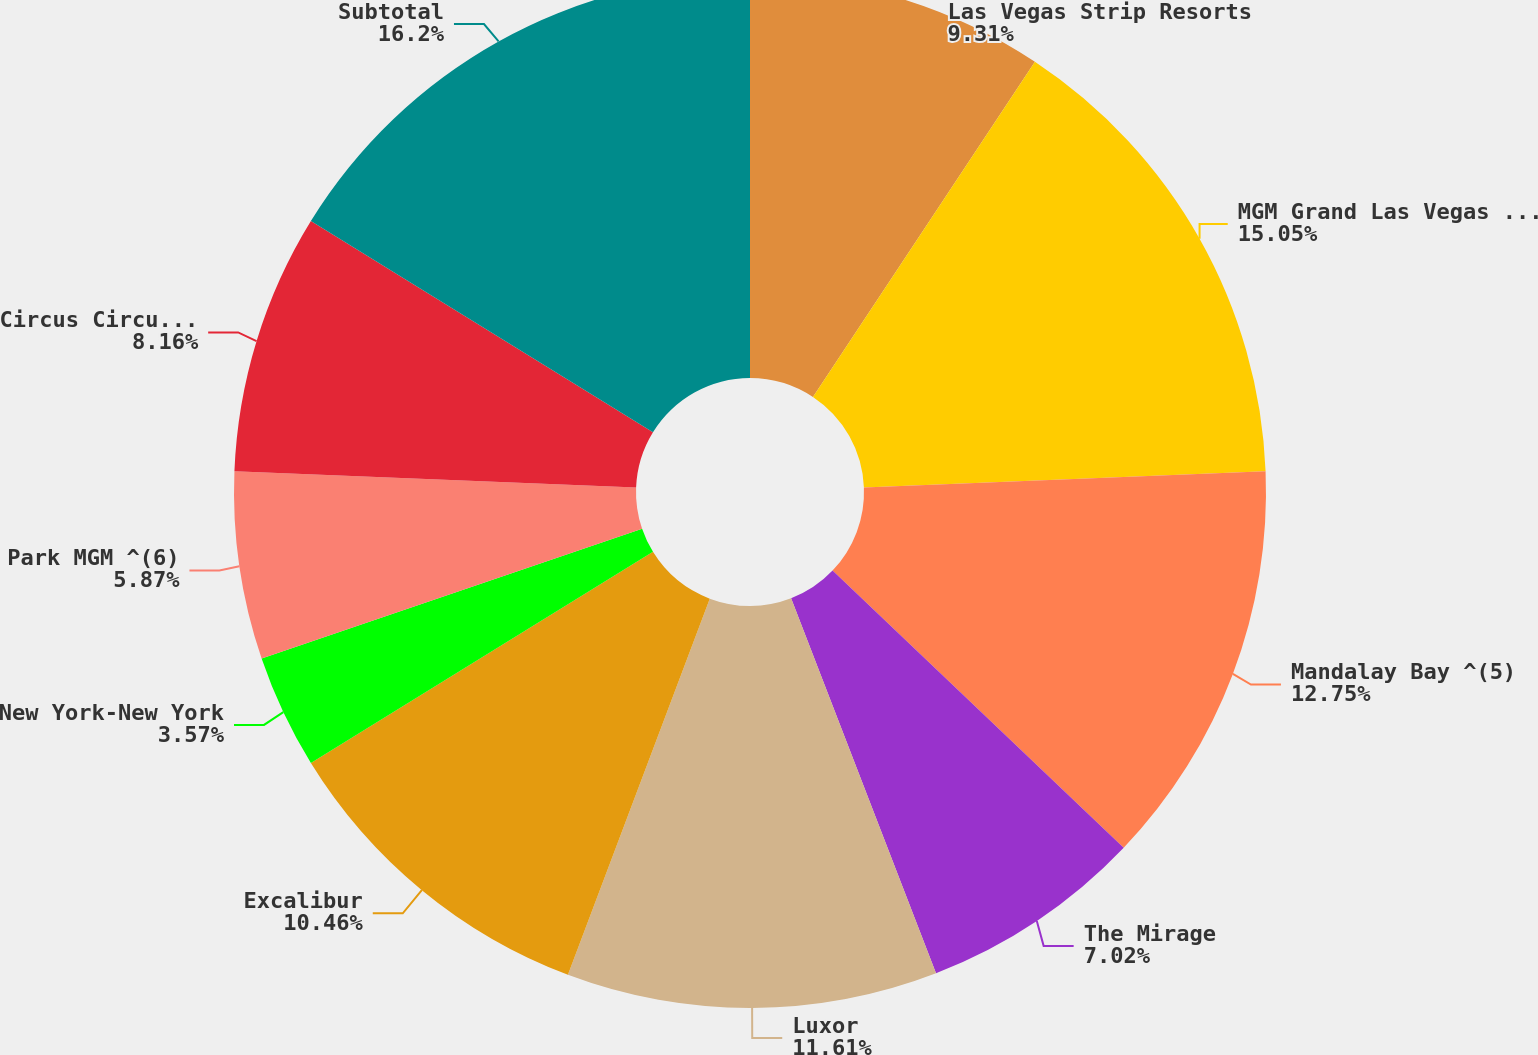Convert chart. <chart><loc_0><loc_0><loc_500><loc_500><pie_chart><fcel>Las Vegas Strip Resorts<fcel>MGM Grand Las Vegas ^(4)<fcel>Mandalay Bay ^(5)<fcel>The Mirage<fcel>Luxor<fcel>Excalibur<fcel>New York-New York<fcel>Park MGM ^(6)<fcel>Circus Circus Las Vegas<fcel>Subtotal<nl><fcel>9.31%<fcel>15.05%<fcel>12.75%<fcel>7.02%<fcel>11.61%<fcel>10.46%<fcel>3.57%<fcel>5.87%<fcel>8.16%<fcel>16.2%<nl></chart> 